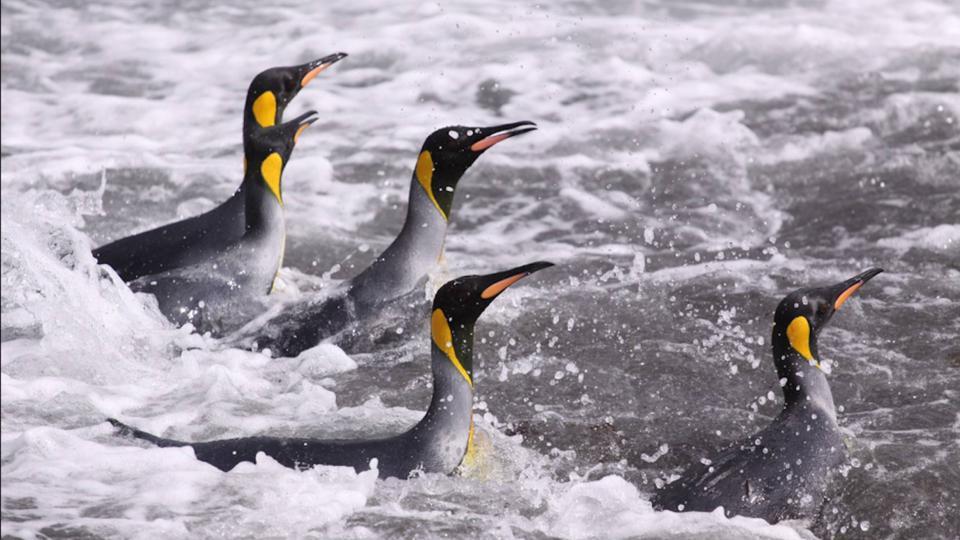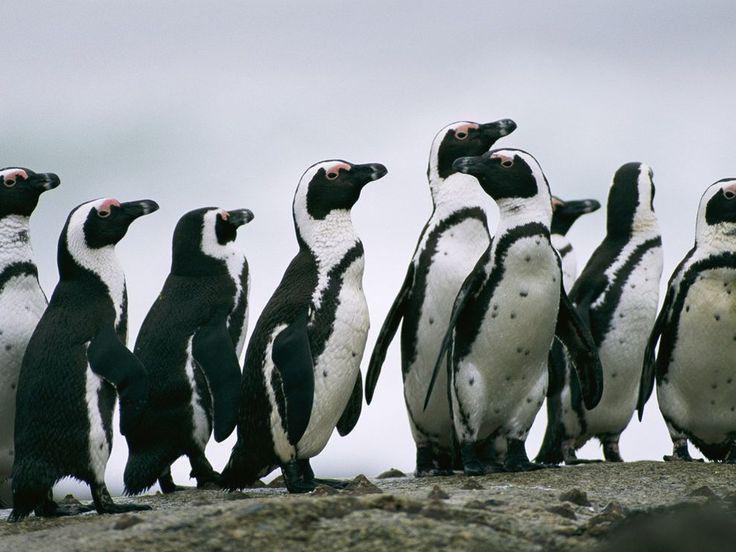The first image is the image on the left, the second image is the image on the right. For the images displayed, is the sentence "The left image has no more than 4 penguins" factually correct? Answer yes or no. No. The first image is the image on the left, the second image is the image on the right. For the images shown, is this caption "In one image the penguins are in the water" true? Answer yes or no. Yes. 